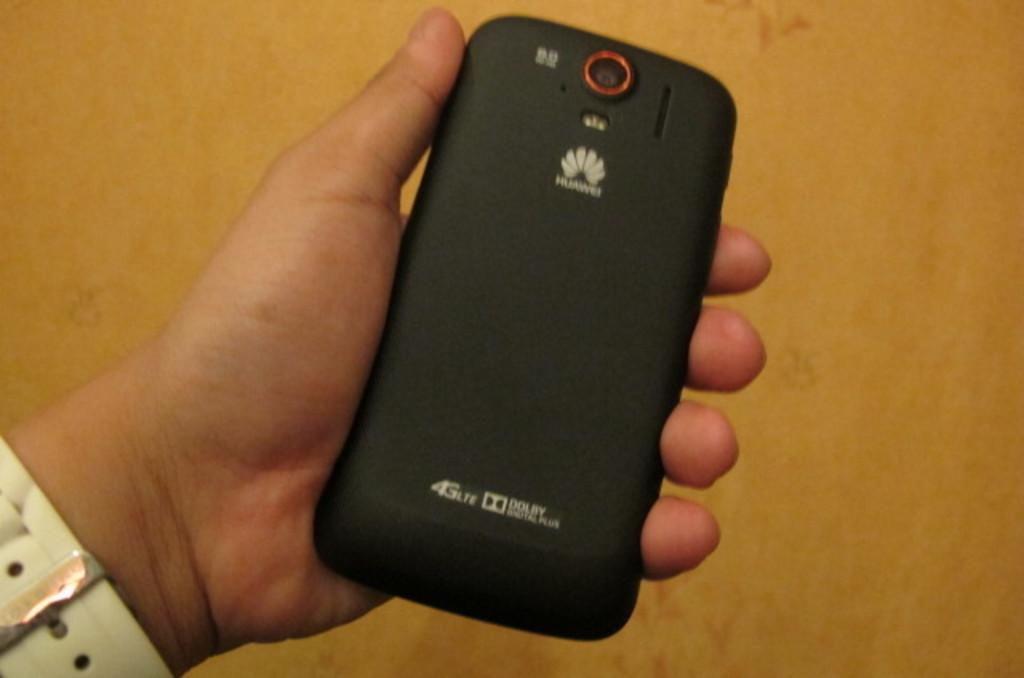<image>
Present a compact description of the photo's key features. A hand holding a black HUAWEI smartphone that is 4G LTE compatible 